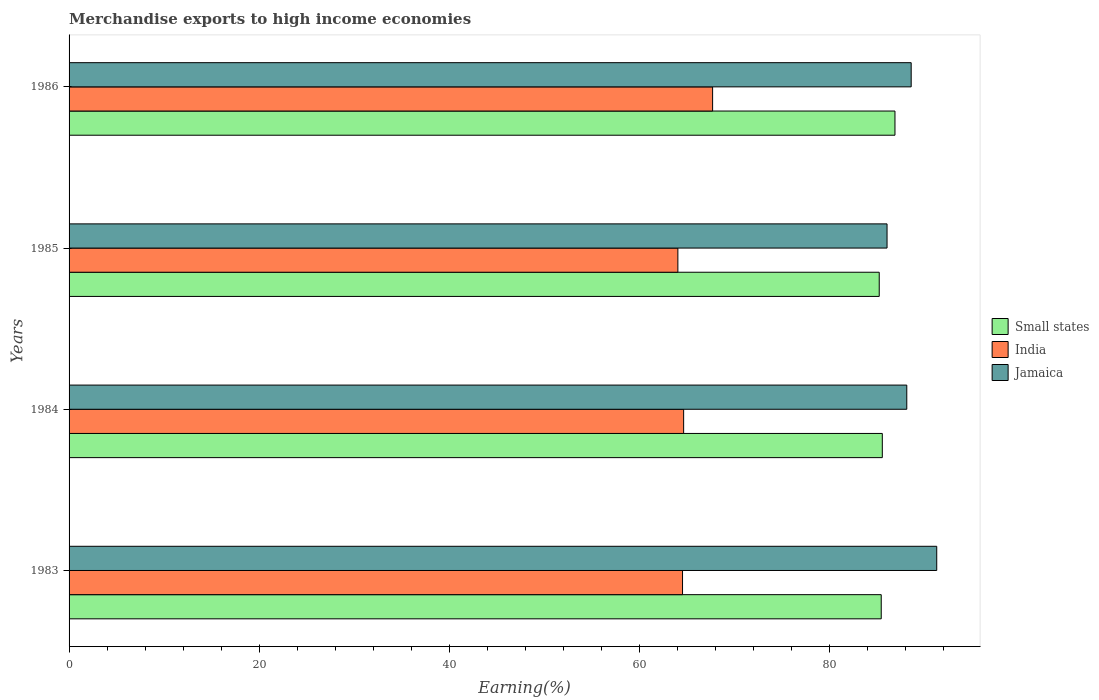How many groups of bars are there?
Keep it short and to the point. 4. Are the number of bars on each tick of the Y-axis equal?
Your response must be concise. Yes. What is the label of the 1st group of bars from the top?
Offer a very short reply. 1986. What is the percentage of amount earned from merchandise exports in India in 1983?
Make the answer very short. 64.57. Across all years, what is the maximum percentage of amount earned from merchandise exports in Jamaica?
Offer a terse response. 91.33. Across all years, what is the minimum percentage of amount earned from merchandise exports in Jamaica?
Make the answer very short. 86.1. In which year was the percentage of amount earned from merchandise exports in India maximum?
Offer a terse response. 1986. What is the total percentage of amount earned from merchandise exports in Jamaica in the graph?
Provide a succinct answer. 354.24. What is the difference between the percentage of amount earned from merchandise exports in Jamaica in 1985 and that in 1986?
Your answer should be very brief. -2.54. What is the difference between the percentage of amount earned from merchandise exports in Jamaica in 1985 and the percentage of amount earned from merchandise exports in Small states in 1983?
Offer a very short reply. 0.61. What is the average percentage of amount earned from merchandise exports in India per year?
Your response must be concise. 65.27. In the year 1986, what is the difference between the percentage of amount earned from merchandise exports in Jamaica and percentage of amount earned from merchandise exports in Small states?
Your answer should be very brief. 1.71. What is the ratio of the percentage of amount earned from merchandise exports in Jamaica in 1984 to that in 1986?
Offer a very short reply. 0.99. What is the difference between the highest and the second highest percentage of amount earned from merchandise exports in Jamaica?
Provide a short and direct response. 2.69. What is the difference between the highest and the lowest percentage of amount earned from merchandise exports in Small states?
Provide a short and direct response. 1.66. In how many years, is the percentage of amount earned from merchandise exports in Jamaica greater than the average percentage of amount earned from merchandise exports in Jamaica taken over all years?
Provide a short and direct response. 2. Is the sum of the percentage of amount earned from merchandise exports in India in 1984 and 1986 greater than the maximum percentage of amount earned from merchandise exports in Small states across all years?
Your answer should be compact. Yes. What does the 1st bar from the top in 1983 represents?
Offer a terse response. Jamaica. What does the 3rd bar from the bottom in 1986 represents?
Provide a short and direct response. Jamaica. Is it the case that in every year, the sum of the percentage of amount earned from merchandise exports in India and percentage of amount earned from merchandise exports in Small states is greater than the percentage of amount earned from merchandise exports in Jamaica?
Your answer should be compact. Yes. Are all the bars in the graph horizontal?
Provide a short and direct response. Yes. How many years are there in the graph?
Provide a succinct answer. 4. Are the values on the major ticks of X-axis written in scientific E-notation?
Ensure brevity in your answer.  No. Does the graph contain grids?
Ensure brevity in your answer.  No. Where does the legend appear in the graph?
Your answer should be very brief. Center right. How are the legend labels stacked?
Provide a short and direct response. Vertical. What is the title of the graph?
Make the answer very short. Merchandise exports to high income economies. What is the label or title of the X-axis?
Provide a short and direct response. Earning(%). What is the label or title of the Y-axis?
Make the answer very short. Years. What is the Earning(%) in Small states in 1983?
Ensure brevity in your answer.  85.49. What is the Earning(%) in India in 1983?
Offer a very short reply. 64.57. What is the Earning(%) of Jamaica in 1983?
Your answer should be very brief. 91.33. What is the Earning(%) in Small states in 1984?
Your answer should be compact. 85.6. What is the Earning(%) in India in 1984?
Ensure brevity in your answer.  64.69. What is the Earning(%) of Jamaica in 1984?
Ensure brevity in your answer.  88.17. What is the Earning(%) of Small states in 1985?
Your response must be concise. 85.27. What is the Earning(%) of India in 1985?
Your answer should be very brief. 64.08. What is the Earning(%) in Jamaica in 1985?
Offer a very short reply. 86.1. What is the Earning(%) of Small states in 1986?
Your response must be concise. 86.93. What is the Earning(%) of India in 1986?
Ensure brevity in your answer.  67.74. What is the Earning(%) in Jamaica in 1986?
Offer a terse response. 88.64. Across all years, what is the maximum Earning(%) in Small states?
Your response must be concise. 86.93. Across all years, what is the maximum Earning(%) of India?
Keep it short and to the point. 67.74. Across all years, what is the maximum Earning(%) of Jamaica?
Provide a short and direct response. 91.33. Across all years, what is the minimum Earning(%) of Small states?
Offer a terse response. 85.27. Across all years, what is the minimum Earning(%) in India?
Your response must be concise. 64.08. Across all years, what is the minimum Earning(%) in Jamaica?
Offer a terse response. 86.1. What is the total Earning(%) in Small states in the graph?
Provide a succinct answer. 343.29. What is the total Earning(%) of India in the graph?
Make the answer very short. 261.07. What is the total Earning(%) of Jamaica in the graph?
Offer a very short reply. 354.24. What is the difference between the Earning(%) of Small states in 1983 and that in 1984?
Provide a succinct answer. -0.11. What is the difference between the Earning(%) in India in 1983 and that in 1984?
Offer a very short reply. -0.12. What is the difference between the Earning(%) in Jamaica in 1983 and that in 1984?
Provide a succinct answer. 3.15. What is the difference between the Earning(%) in Small states in 1983 and that in 1985?
Provide a short and direct response. 0.21. What is the difference between the Earning(%) of India in 1983 and that in 1985?
Offer a terse response. 0.49. What is the difference between the Earning(%) of Jamaica in 1983 and that in 1985?
Your answer should be very brief. 5.23. What is the difference between the Earning(%) in Small states in 1983 and that in 1986?
Your answer should be compact. -1.44. What is the difference between the Earning(%) in India in 1983 and that in 1986?
Provide a succinct answer. -3.17. What is the difference between the Earning(%) in Jamaica in 1983 and that in 1986?
Your answer should be very brief. 2.69. What is the difference between the Earning(%) in Small states in 1984 and that in 1985?
Provide a succinct answer. 0.33. What is the difference between the Earning(%) in India in 1984 and that in 1985?
Offer a very short reply. 0.61. What is the difference between the Earning(%) of Jamaica in 1984 and that in 1985?
Your answer should be compact. 2.08. What is the difference between the Earning(%) in Small states in 1984 and that in 1986?
Keep it short and to the point. -1.33. What is the difference between the Earning(%) in India in 1984 and that in 1986?
Offer a terse response. -3.05. What is the difference between the Earning(%) of Jamaica in 1984 and that in 1986?
Your answer should be very brief. -0.46. What is the difference between the Earning(%) in Small states in 1985 and that in 1986?
Your response must be concise. -1.66. What is the difference between the Earning(%) in India in 1985 and that in 1986?
Your answer should be compact. -3.66. What is the difference between the Earning(%) of Jamaica in 1985 and that in 1986?
Your response must be concise. -2.54. What is the difference between the Earning(%) in Small states in 1983 and the Earning(%) in India in 1984?
Make the answer very short. 20.8. What is the difference between the Earning(%) of Small states in 1983 and the Earning(%) of Jamaica in 1984?
Provide a succinct answer. -2.69. What is the difference between the Earning(%) in India in 1983 and the Earning(%) in Jamaica in 1984?
Give a very brief answer. -23.6. What is the difference between the Earning(%) of Small states in 1983 and the Earning(%) of India in 1985?
Your answer should be very brief. 21.41. What is the difference between the Earning(%) in Small states in 1983 and the Earning(%) in Jamaica in 1985?
Your answer should be very brief. -0.61. What is the difference between the Earning(%) of India in 1983 and the Earning(%) of Jamaica in 1985?
Make the answer very short. -21.53. What is the difference between the Earning(%) in Small states in 1983 and the Earning(%) in India in 1986?
Provide a succinct answer. 17.75. What is the difference between the Earning(%) of Small states in 1983 and the Earning(%) of Jamaica in 1986?
Your response must be concise. -3.15. What is the difference between the Earning(%) in India in 1983 and the Earning(%) in Jamaica in 1986?
Offer a very short reply. -24.07. What is the difference between the Earning(%) in Small states in 1984 and the Earning(%) in India in 1985?
Provide a short and direct response. 21.52. What is the difference between the Earning(%) in Small states in 1984 and the Earning(%) in Jamaica in 1985?
Give a very brief answer. -0.5. What is the difference between the Earning(%) in India in 1984 and the Earning(%) in Jamaica in 1985?
Offer a very short reply. -21.41. What is the difference between the Earning(%) in Small states in 1984 and the Earning(%) in India in 1986?
Keep it short and to the point. 17.86. What is the difference between the Earning(%) in Small states in 1984 and the Earning(%) in Jamaica in 1986?
Your response must be concise. -3.04. What is the difference between the Earning(%) of India in 1984 and the Earning(%) of Jamaica in 1986?
Offer a terse response. -23.95. What is the difference between the Earning(%) of Small states in 1985 and the Earning(%) of India in 1986?
Keep it short and to the point. 17.54. What is the difference between the Earning(%) of Small states in 1985 and the Earning(%) of Jamaica in 1986?
Give a very brief answer. -3.36. What is the difference between the Earning(%) in India in 1985 and the Earning(%) in Jamaica in 1986?
Your answer should be very brief. -24.56. What is the average Earning(%) in Small states per year?
Your response must be concise. 85.82. What is the average Earning(%) of India per year?
Provide a succinct answer. 65.27. What is the average Earning(%) of Jamaica per year?
Your response must be concise. 88.56. In the year 1983, what is the difference between the Earning(%) in Small states and Earning(%) in India?
Your response must be concise. 20.91. In the year 1983, what is the difference between the Earning(%) of Small states and Earning(%) of Jamaica?
Make the answer very short. -5.84. In the year 1983, what is the difference between the Earning(%) in India and Earning(%) in Jamaica?
Provide a succinct answer. -26.76. In the year 1984, what is the difference between the Earning(%) of Small states and Earning(%) of India?
Your response must be concise. 20.91. In the year 1984, what is the difference between the Earning(%) in Small states and Earning(%) in Jamaica?
Your answer should be compact. -2.57. In the year 1984, what is the difference between the Earning(%) of India and Earning(%) of Jamaica?
Offer a very short reply. -23.49. In the year 1985, what is the difference between the Earning(%) of Small states and Earning(%) of India?
Ensure brevity in your answer.  21.19. In the year 1985, what is the difference between the Earning(%) of Small states and Earning(%) of Jamaica?
Keep it short and to the point. -0.82. In the year 1985, what is the difference between the Earning(%) in India and Earning(%) in Jamaica?
Give a very brief answer. -22.02. In the year 1986, what is the difference between the Earning(%) in Small states and Earning(%) in India?
Ensure brevity in your answer.  19.19. In the year 1986, what is the difference between the Earning(%) of Small states and Earning(%) of Jamaica?
Provide a succinct answer. -1.71. In the year 1986, what is the difference between the Earning(%) in India and Earning(%) in Jamaica?
Offer a very short reply. -20.9. What is the ratio of the Earning(%) in Small states in 1983 to that in 1984?
Give a very brief answer. 1. What is the ratio of the Earning(%) in Jamaica in 1983 to that in 1984?
Offer a terse response. 1.04. What is the ratio of the Earning(%) in Small states in 1983 to that in 1985?
Give a very brief answer. 1. What is the ratio of the Earning(%) of India in 1983 to that in 1985?
Your answer should be very brief. 1.01. What is the ratio of the Earning(%) in Jamaica in 1983 to that in 1985?
Your answer should be very brief. 1.06. What is the ratio of the Earning(%) of Small states in 1983 to that in 1986?
Make the answer very short. 0.98. What is the ratio of the Earning(%) in India in 1983 to that in 1986?
Your answer should be compact. 0.95. What is the ratio of the Earning(%) in Jamaica in 1983 to that in 1986?
Ensure brevity in your answer.  1.03. What is the ratio of the Earning(%) in India in 1984 to that in 1985?
Give a very brief answer. 1.01. What is the ratio of the Earning(%) in Jamaica in 1984 to that in 1985?
Your response must be concise. 1.02. What is the ratio of the Earning(%) of Small states in 1984 to that in 1986?
Make the answer very short. 0.98. What is the ratio of the Earning(%) in India in 1984 to that in 1986?
Make the answer very short. 0.95. What is the ratio of the Earning(%) of Jamaica in 1984 to that in 1986?
Provide a short and direct response. 0.99. What is the ratio of the Earning(%) in Small states in 1985 to that in 1986?
Offer a very short reply. 0.98. What is the ratio of the Earning(%) in India in 1985 to that in 1986?
Provide a short and direct response. 0.95. What is the ratio of the Earning(%) in Jamaica in 1985 to that in 1986?
Provide a succinct answer. 0.97. What is the difference between the highest and the second highest Earning(%) in Small states?
Keep it short and to the point. 1.33. What is the difference between the highest and the second highest Earning(%) of India?
Provide a succinct answer. 3.05. What is the difference between the highest and the second highest Earning(%) of Jamaica?
Ensure brevity in your answer.  2.69. What is the difference between the highest and the lowest Earning(%) in Small states?
Offer a very short reply. 1.66. What is the difference between the highest and the lowest Earning(%) of India?
Offer a terse response. 3.66. What is the difference between the highest and the lowest Earning(%) of Jamaica?
Make the answer very short. 5.23. 